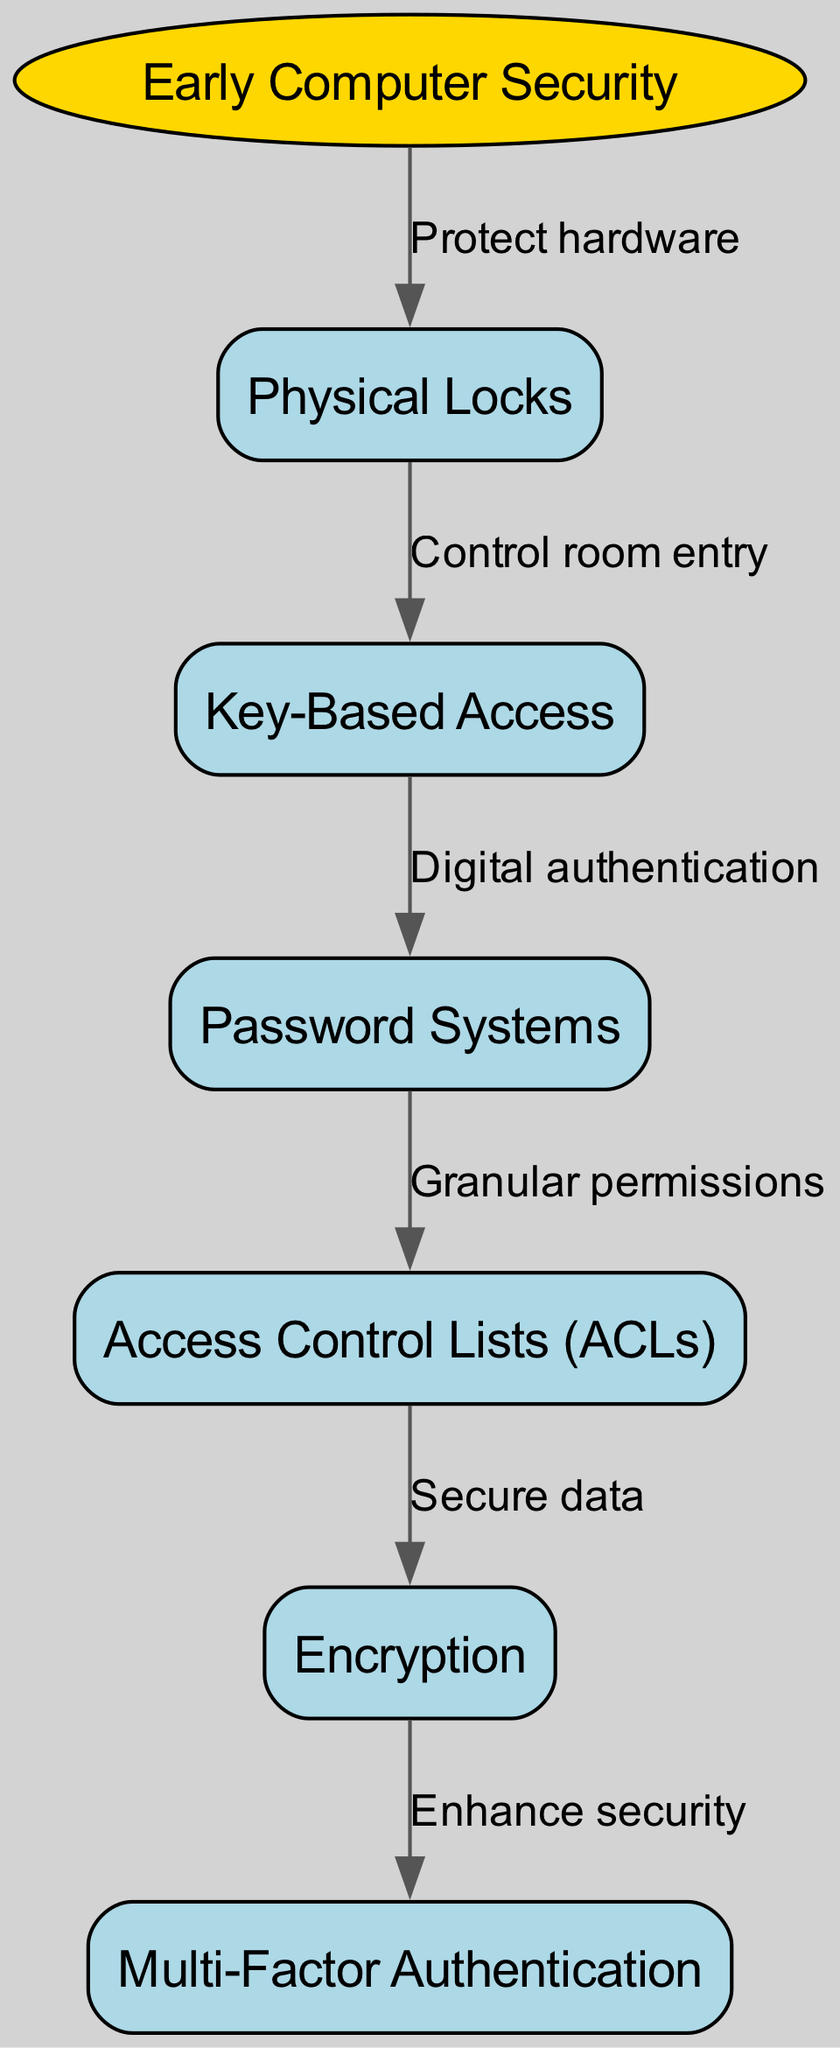What is the starting point of the flow chart? The starting point of the flow chart is labeled "Early Computer Security," as indicated by the node that initiates the flow of the diagram.
Answer: Early Computer Security How many nodes are there in total in the diagram? The total number of nodes includes both the starting node and the subsequent nodes. Counting the starting node "Early Computer Security" plus the other five nodes, we have a total of six nodes.
Answer: 6 What label connects "Physical Locks" to "Key-Based Access"? The edge connecting "Physical Locks" to "Key-Based Access" is labeled "Control room entry," which indicates the relationship and function between these two nodes in the flow.
Answer: Control room entry What is the last step in the development process according to the diagram? The last step in the development process is represented by "Multi-Factor Authentication," which is the endpoint of the flow chart, demonstrating the final evolution of security systems.
Answer: Multi-Factor Authentication Which node introduces digital authentication? The node that introduces digital authentication is "Key-Based Access," as it directly flows into "Password Systems," indicating a transition from physical to digital means of access control.
Answer: Key-Based Access Which edge connects "Access Control Lists (ACLs)" to "Encryption"? The edge connecting these two nodes is labeled "Secure data," showing that access control lists are related to the necessity of securing data through encryption.
Answer: Secure data What node enhances security after encryption? After the encryption node, "Multi-Factor Authentication" is presented as the next step, indicating a progression toward enhanced security measures.
Answer: Multi-Factor Authentication What function do Access Control Lists (ACLs) provide in the flow? Access Control Lists (ACLs) provide "Granular permissions," indicating that they enable more specific control over who can access what resources within a system.
Answer: Granular permissions Which two nodes are directly connected by the edge labeled 'Enhance security'? The nodes that are directly connected by the edge labeled 'Enhance security' are "Encryption" and "Multi-Factor Authentication," showing the relationship between these security measures.
Answer: Encryption and Multi-Factor Authentication 